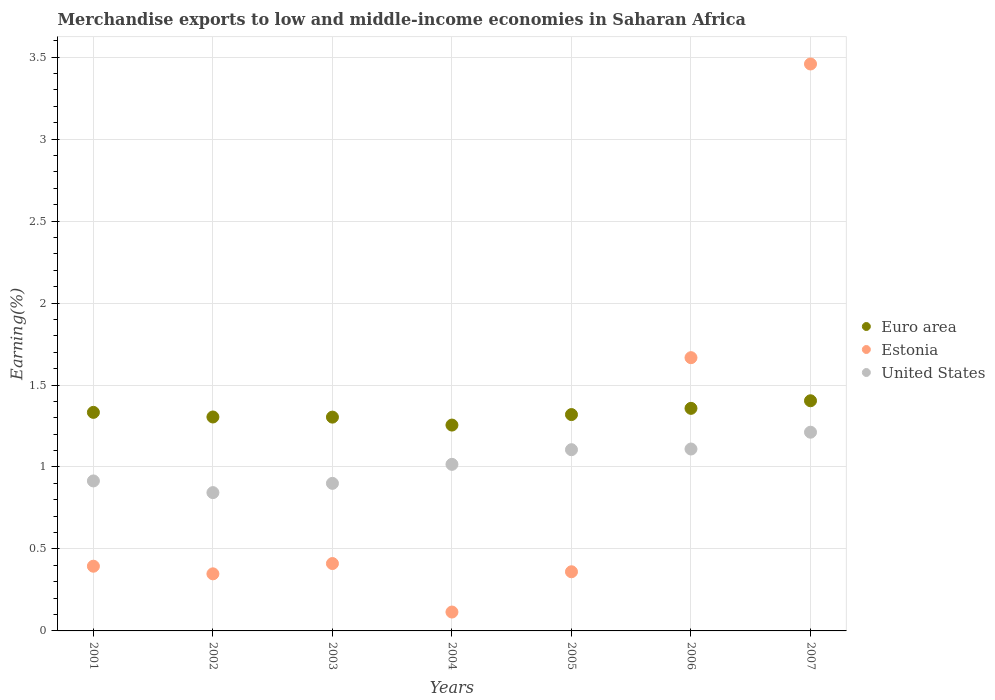How many different coloured dotlines are there?
Keep it short and to the point. 3. What is the percentage of amount earned from merchandise exports in United States in 2003?
Provide a succinct answer. 0.9. Across all years, what is the maximum percentage of amount earned from merchandise exports in Euro area?
Offer a very short reply. 1.4. Across all years, what is the minimum percentage of amount earned from merchandise exports in United States?
Provide a succinct answer. 0.84. In which year was the percentage of amount earned from merchandise exports in Estonia maximum?
Provide a short and direct response. 2007. In which year was the percentage of amount earned from merchandise exports in United States minimum?
Give a very brief answer. 2002. What is the total percentage of amount earned from merchandise exports in United States in the graph?
Provide a short and direct response. 7.1. What is the difference between the percentage of amount earned from merchandise exports in Estonia in 2002 and that in 2004?
Your answer should be compact. 0.23. What is the difference between the percentage of amount earned from merchandise exports in United States in 2006 and the percentage of amount earned from merchandise exports in Euro area in 2005?
Make the answer very short. -0.21. What is the average percentage of amount earned from merchandise exports in Estonia per year?
Make the answer very short. 0.97. In the year 2002, what is the difference between the percentage of amount earned from merchandise exports in Estonia and percentage of amount earned from merchandise exports in Euro area?
Provide a succinct answer. -0.96. What is the ratio of the percentage of amount earned from merchandise exports in United States in 2003 to that in 2006?
Offer a very short reply. 0.81. What is the difference between the highest and the second highest percentage of amount earned from merchandise exports in Euro area?
Your response must be concise. 0.05. What is the difference between the highest and the lowest percentage of amount earned from merchandise exports in Estonia?
Your answer should be very brief. 3.34. Is the sum of the percentage of amount earned from merchandise exports in Estonia in 2005 and 2006 greater than the maximum percentage of amount earned from merchandise exports in United States across all years?
Provide a succinct answer. Yes. Is it the case that in every year, the sum of the percentage of amount earned from merchandise exports in Euro area and percentage of amount earned from merchandise exports in United States  is greater than the percentage of amount earned from merchandise exports in Estonia?
Your response must be concise. No. Is the percentage of amount earned from merchandise exports in United States strictly greater than the percentage of amount earned from merchandise exports in Euro area over the years?
Offer a very short reply. No. Is the percentage of amount earned from merchandise exports in Euro area strictly less than the percentage of amount earned from merchandise exports in Estonia over the years?
Offer a terse response. No. How many dotlines are there?
Your answer should be compact. 3. Does the graph contain any zero values?
Give a very brief answer. No. How are the legend labels stacked?
Your response must be concise. Vertical. What is the title of the graph?
Keep it short and to the point. Merchandise exports to low and middle-income economies in Saharan Africa. Does "Dominica" appear as one of the legend labels in the graph?
Offer a terse response. No. What is the label or title of the X-axis?
Your response must be concise. Years. What is the label or title of the Y-axis?
Your answer should be compact. Earning(%). What is the Earning(%) in Euro area in 2001?
Provide a succinct answer. 1.33. What is the Earning(%) of Estonia in 2001?
Provide a succinct answer. 0.39. What is the Earning(%) in United States in 2001?
Provide a short and direct response. 0.91. What is the Earning(%) in Euro area in 2002?
Give a very brief answer. 1.31. What is the Earning(%) in Estonia in 2002?
Your response must be concise. 0.35. What is the Earning(%) in United States in 2002?
Ensure brevity in your answer.  0.84. What is the Earning(%) in Euro area in 2003?
Provide a succinct answer. 1.3. What is the Earning(%) of Estonia in 2003?
Make the answer very short. 0.41. What is the Earning(%) in United States in 2003?
Provide a succinct answer. 0.9. What is the Earning(%) of Euro area in 2004?
Provide a succinct answer. 1.26. What is the Earning(%) of Estonia in 2004?
Give a very brief answer. 0.12. What is the Earning(%) of United States in 2004?
Provide a short and direct response. 1.02. What is the Earning(%) in Euro area in 2005?
Keep it short and to the point. 1.32. What is the Earning(%) of Estonia in 2005?
Your answer should be very brief. 0.36. What is the Earning(%) in United States in 2005?
Offer a very short reply. 1.11. What is the Earning(%) of Euro area in 2006?
Offer a very short reply. 1.36. What is the Earning(%) of Estonia in 2006?
Give a very brief answer. 1.67. What is the Earning(%) in United States in 2006?
Offer a very short reply. 1.11. What is the Earning(%) of Euro area in 2007?
Your answer should be compact. 1.4. What is the Earning(%) in Estonia in 2007?
Ensure brevity in your answer.  3.46. What is the Earning(%) in United States in 2007?
Keep it short and to the point. 1.21. Across all years, what is the maximum Earning(%) of Euro area?
Provide a succinct answer. 1.4. Across all years, what is the maximum Earning(%) of Estonia?
Your answer should be very brief. 3.46. Across all years, what is the maximum Earning(%) in United States?
Offer a terse response. 1.21. Across all years, what is the minimum Earning(%) in Euro area?
Keep it short and to the point. 1.26. Across all years, what is the minimum Earning(%) in Estonia?
Offer a terse response. 0.12. Across all years, what is the minimum Earning(%) in United States?
Make the answer very short. 0.84. What is the total Earning(%) of Euro area in the graph?
Your answer should be very brief. 9.28. What is the total Earning(%) in Estonia in the graph?
Provide a short and direct response. 6.76. What is the total Earning(%) in United States in the graph?
Provide a short and direct response. 7.1. What is the difference between the Earning(%) of Euro area in 2001 and that in 2002?
Provide a succinct answer. 0.03. What is the difference between the Earning(%) in Estonia in 2001 and that in 2002?
Give a very brief answer. 0.05. What is the difference between the Earning(%) of United States in 2001 and that in 2002?
Your answer should be very brief. 0.07. What is the difference between the Earning(%) of Euro area in 2001 and that in 2003?
Keep it short and to the point. 0.03. What is the difference between the Earning(%) in Estonia in 2001 and that in 2003?
Make the answer very short. -0.02. What is the difference between the Earning(%) of United States in 2001 and that in 2003?
Give a very brief answer. 0.01. What is the difference between the Earning(%) in Euro area in 2001 and that in 2004?
Offer a very short reply. 0.08. What is the difference between the Earning(%) of Estonia in 2001 and that in 2004?
Your response must be concise. 0.28. What is the difference between the Earning(%) in United States in 2001 and that in 2004?
Offer a very short reply. -0.1. What is the difference between the Earning(%) of Euro area in 2001 and that in 2005?
Offer a terse response. 0.01. What is the difference between the Earning(%) in Estonia in 2001 and that in 2005?
Your answer should be compact. 0.03. What is the difference between the Earning(%) of United States in 2001 and that in 2005?
Give a very brief answer. -0.19. What is the difference between the Earning(%) in Euro area in 2001 and that in 2006?
Ensure brevity in your answer.  -0.02. What is the difference between the Earning(%) of Estonia in 2001 and that in 2006?
Provide a short and direct response. -1.27. What is the difference between the Earning(%) of United States in 2001 and that in 2006?
Provide a succinct answer. -0.19. What is the difference between the Earning(%) in Euro area in 2001 and that in 2007?
Your response must be concise. -0.07. What is the difference between the Earning(%) of Estonia in 2001 and that in 2007?
Make the answer very short. -3.06. What is the difference between the Earning(%) of United States in 2001 and that in 2007?
Your answer should be very brief. -0.3. What is the difference between the Earning(%) in Euro area in 2002 and that in 2003?
Ensure brevity in your answer.  0. What is the difference between the Earning(%) in Estonia in 2002 and that in 2003?
Ensure brevity in your answer.  -0.06. What is the difference between the Earning(%) of United States in 2002 and that in 2003?
Ensure brevity in your answer.  -0.06. What is the difference between the Earning(%) of Euro area in 2002 and that in 2004?
Give a very brief answer. 0.05. What is the difference between the Earning(%) of Estonia in 2002 and that in 2004?
Offer a terse response. 0.23. What is the difference between the Earning(%) of United States in 2002 and that in 2004?
Your answer should be very brief. -0.17. What is the difference between the Earning(%) in Euro area in 2002 and that in 2005?
Your answer should be very brief. -0.01. What is the difference between the Earning(%) of Estonia in 2002 and that in 2005?
Your response must be concise. -0.01. What is the difference between the Earning(%) of United States in 2002 and that in 2005?
Make the answer very short. -0.26. What is the difference between the Earning(%) in Euro area in 2002 and that in 2006?
Offer a very short reply. -0.05. What is the difference between the Earning(%) of Estonia in 2002 and that in 2006?
Give a very brief answer. -1.32. What is the difference between the Earning(%) in United States in 2002 and that in 2006?
Provide a short and direct response. -0.27. What is the difference between the Earning(%) in Euro area in 2002 and that in 2007?
Provide a short and direct response. -0.1. What is the difference between the Earning(%) of Estonia in 2002 and that in 2007?
Your response must be concise. -3.11. What is the difference between the Earning(%) of United States in 2002 and that in 2007?
Keep it short and to the point. -0.37. What is the difference between the Earning(%) of Euro area in 2003 and that in 2004?
Keep it short and to the point. 0.05. What is the difference between the Earning(%) of Estonia in 2003 and that in 2004?
Your response must be concise. 0.3. What is the difference between the Earning(%) of United States in 2003 and that in 2004?
Make the answer very short. -0.12. What is the difference between the Earning(%) of Euro area in 2003 and that in 2005?
Offer a very short reply. -0.02. What is the difference between the Earning(%) of Estonia in 2003 and that in 2005?
Provide a succinct answer. 0.05. What is the difference between the Earning(%) of United States in 2003 and that in 2005?
Offer a terse response. -0.21. What is the difference between the Earning(%) of Euro area in 2003 and that in 2006?
Your response must be concise. -0.05. What is the difference between the Earning(%) in Estonia in 2003 and that in 2006?
Offer a very short reply. -1.26. What is the difference between the Earning(%) in United States in 2003 and that in 2006?
Keep it short and to the point. -0.21. What is the difference between the Earning(%) in Euro area in 2003 and that in 2007?
Your answer should be very brief. -0.1. What is the difference between the Earning(%) of Estonia in 2003 and that in 2007?
Your response must be concise. -3.05. What is the difference between the Earning(%) in United States in 2003 and that in 2007?
Make the answer very short. -0.31. What is the difference between the Earning(%) in Euro area in 2004 and that in 2005?
Your response must be concise. -0.06. What is the difference between the Earning(%) of Estonia in 2004 and that in 2005?
Keep it short and to the point. -0.25. What is the difference between the Earning(%) of United States in 2004 and that in 2005?
Give a very brief answer. -0.09. What is the difference between the Earning(%) in Euro area in 2004 and that in 2006?
Your answer should be very brief. -0.1. What is the difference between the Earning(%) of Estonia in 2004 and that in 2006?
Keep it short and to the point. -1.55. What is the difference between the Earning(%) in United States in 2004 and that in 2006?
Your answer should be compact. -0.09. What is the difference between the Earning(%) in Euro area in 2004 and that in 2007?
Offer a terse response. -0.15. What is the difference between the Earning(%) of Estonia in 2004 and that in 2007?
Ensure brevity in your answer.  -3.34. What is the difference between the Earning(%) of United States in 2004 and that in 2007?
Make the answer very short. -0.2. What is the difference between the Earning(%) of Euro area in 2005 and that in 2006?
Your answer should be very brief. -0.04. What is the difference between the Earning(%) in Estonia in 2005 and that in 2006?
Provide a short and direct response. -1.31. What is the difference between the Earning(%) in United States in 2005 and that in 2006?
Provide a short and direct response. -0. What is the difference between the Earning(%) in Euro area in 2005 and that in 2007?
Your response must be concise. -0.08. What is the difference between the Earning(%) of Estonia in 2005 and that in 2007?
Give a very brief answer. -3.1. What is the difference between the Earning(%) in United States in 2005 and that in 2007?
Keep it short and to the point. -0.11. What is the difference between the Earning(%) of Euro area in 2006 and that in 2007?
Ensure brevity in your answer.  -0.05. What is the difference between the Earning(%) in Estonia in 2006 and that in 2007?
Make the answer very short. -1.79. What is the difference between the Earning(%) in United States in 2006 and that in 2007?
Give a very brief answer. -0.1. What is the difference between the Earning(%) in Euro area in 2001 and the Earning(%) in Estonia in 2002?
Provide a succinct answer. 0.98. What is the difference between the Earning(%) of Euro area in 2001 and the Earning(%) of United States in 2002?
Provide a short and direct response. 0.49. What is the difference between the Earning(%) in Estonia in 2001 and the Earning(%) in United States in 2002?
Keep it short and to the point. -0.45. What is the difference between the Earning(%) of Euro area in 2001 and the Earning(%) of Estonia in 2003?
Provide a succinct answer. 0.92. What is the difference between the Earning(%) of Euro area in 2001 and the Earning(%) of United States in 2003?
Your answer should be very brief. 0.43. What is the difference between the Earning(%) in Estonia in 2001 and the Earning(%) in United States in 2003?
Make the answer very short. -0.51. What is the difference between the Earning(%) in Euro area in 2001 and the Earning(%) in Estonia in 2004?
Make the answer very short. 1.22. What is the difference between the Earning(%) of Euro area in 2001 and the Earning(%) of United States in 2004?
Make the answer very short. 0.32. What is the difference between the Earning(%) in Estonia in 2001 and the Earning(%) in United States in 2004?
Your answer should be very brief. -0.62. What is the difference between the Earning(%) in Euro area in 2001 and the Earning(%) in Estonia in 2005?
Make the answer very short. 0.97. What is the difference between the Earning(%) in Euro area in 2001 and the Earning(%) in United States in 2005?
Provide a succinct answer. 0.23. What is the difference between the Earning(%) in Estonia in 2001 and the Earning(%) in United States in 2005?
Make the answer very short. -0.71. What is the difference between the Earning(%) in Euro area in 2001 and the Earning(%) in Estonia in 2006?
Give a very brief answer. -0.33. What is the difference between the Earning(%) of Euro area in 2001 and the Earning(%) of United States in 2006?
Keep it short and to the point. 0.22. What is the difference between the Earning(%) of Estonia in 2001 and the Earning(%) of United States in 2006?
Make the answer very short. -0.71. What is the difference between the Earning(%) in Euro area in 2001 and the Earning(%) in Estonia in 2007?
Your answer should be very brief. -2.13. What is the difference between the Earning(%) in Euro area in 2001 and the Earning(%) in United States in 2007?
Make the answer very short. 0.12. What is the difference between the Earning(%) in Estonia in 2001 and the Earning(%) in United States in 2007?
Your response must be concise. -0.82. What is the difference between the Earning(%) of Euro area in 2002 and the Earning(%) of Estonia in 2003?
Make the answer very short. 0.89. What is the difference between the Earning(%) of Euro area in 2002 and the Earning(%) of United States in 2003?
Keep it short and to the point. 0.4. What is the difference between the Earning(%) of Estonia in 2002 and the Earning(%) of United States in 2003?
Make the answer very short. -0.55. What is the difference between the Earning(%) of Euro area in 2002 and the Earning(%) of Estonia in 2004?
Offer a very short reply. 1.19. What is the difference between the Earning(%) of Euro area in 2002 and the Earning(%) of United States in 2004?
Keep it short and to the point. 0.29. What is the difference between the Earning(%) of Estonia in 2002 and the Earning(%) of United States in 2004?
Offer a very short reply. -0.67. What is the difference between the Earning(%) in Euro area in 2002 and the Earning(%) in Estonia in 2005?
Provide a short and direct response. 0.94. What is the difference between the Earning(%) in Euro area in 2002 and the Earning(%) in United States in 2005?
Offer a very short reply. 0.2. What is the difference between the Earning(%) in Estonia in 2002 and the Earning(%) in United States in 2005?
Give a very brief answer. -0.76. What is the difference between the Earning(%) of Euro area in 2002 and the Earning(%) of Estonia in 2006?
Provide a succinct answer. -0.36. What is the difference between the Earning(%) of Euro area in 2002 and the Earning(%) of United States in 2006?
Offer a very short reply. 0.2. What is the difference between the Earning(%) in Estonia in 2002 and the Earning(%) in United States in 2006?
Your answer should be very brief. -0.76. What is the difference between the Earning(%) in Euro area in 2002 and the Earning(%) in Estonia in 2007?
Your answer should be compact. -2.15. What is the difference between the Earning(%) of Euro area in 2002 and the Earning(%) of United States in 2007?
Your response must be concise. 0.09. What is the difference between the Earning(%) in Estonia in 2002 and the Earning(%) in United States in 2007?
Your response must be concise. -0.86. What is the difference between the Earning(%) in Euro area in 2003 and the Earning(%) in Estonia in 2004?
Make the answer very short. 1.19. What is the difference between the Earning(%) in Euro area in 2003 and the Earning(%) in United States in 2004?
Make the answer very short. 0.29. What is the difference between the Earning(%) in Estonia in 2003 and the Earning(%) in United States in 2004?
Your answer should be very brief. -0.61. What is the difference between the Earning(%) in Euro area in 2003 and the Earning(%) in Estonia in 2005?
Offer a terse response. 0.94. What is the difference between the Earning(%) in Euro area in 2003 and the Earning(%) in United States in 2005?
Ensure brevity in your answer.  0.2. What is the difference between the Earning(%) of Estonia in 2003 and the Earning(%) of United States in 2005?
Make the answer very short. -0.69. What is the difference between the Earning(%) in Euro area in 2003 and the Earning(%) in Estonia in 2006?
Ensure brevity in your answer.  -0.36. What is the difference between the Earning(%) of Euro area in 2003 and the Earning(%) of United States in 2006?
Offer a very short reply. 0.19. What is the difference between the Earning(%) of Estonia in 2003 and the Earning(%) of United States in 2006?
Offer a very short reply. -0.7. What is the difference between the Earning(%) in Euro area in 2003 and the Earning(%) in Estonia in 2007?
Keep it short and to the point. -2.15. What is the difference between the Earning(%) of Euro area in 2003 and the Earning(%) of United States in 2007?
Ensure brevity in your answer.  0.09. What is the difference between the Earning(%) of Estonia in 2003 and the Earning(%) of United States in 2007?
Keep it short and to the point. -0.8. What is the difference between the Earning(%) in Euro area in 2004 and the Earning(%) in Estonia in 2005?
Make the answer very short. 0.89. What is the difference between the Earning(%) in Euro area in 2004 and the Earning(%) in United States in 2005?
Give a very brief answer. 0.15. What is the difference between the Earning(%) of Estonia in 2004 and the Earning(%) of United States in 2005?
Provide a succinct answer. -0.99. What is the difference between the Earning(%) of Euro area in 2004 and the Earning(%) of Estonia in 2006?
Give a very brief answer. -0.41. What is the difference between the Earning(%) in Euro area in 2004 and the Earning(%) in United States in 2006?
Your answer should be very brief. 0.15. What is the difference between the Earning(%) in Estonia in 2004 and the Earning(%) in United States in 2006?
Your answer should be compact. -0.99. What is the difference between the Earning(%) of Euro area in 2004 and the Earning(%) of Estonia in 2007?
Offer a very short reply. -2.2. What is the difference between the Earning(%) of Euro area in 2004 and the Earning(%) of United States in 2007?
Offer a terse response. 0.04. What is the difference between the Earning(%) of Estonia in 2004 and the Earning(%) of United States in 2007?
Your answer should be compact. -1.1. What is the difference between the Earning(%) in Euro area in 2005 and the Earning(%) in Estonia in 2006?
Give a very brief answer. -0.35. What is the difference between the Earning(%) of Euro area in 2005 and the Earning(%) of United States in 2006?
Ensure brevity in your answer.  0.21. What is the difference between the Earning(%) of Estonia in 2005 and the Earning(%) of United States in 2006?
Your answer should be compact. -0.75. What is the difference between the Earning(%) in Euro area in 2005 and the Earning(%) in Estonia in 2007?
Your response must be concise. -2.14. What is the difference between the Earning(%) in Euro area in 2005 and the Earning(%) in United States in 2007?
Offer a terse response. 0.11. What is the difference between the Earning(%) in Estonia in 2005 and the Earning(%) in United States in 2007?
Your answer should be compact. -0.85. What is the difference between the Earning(%) of Euro area in 2006 and the Earning(%) of Estonia in 2007?
Offer a very short reply. -2.1. What is the difference between the Earning(%) of Euro area in 2006 and the Earning(%) of United States in 2007?
Offer a terse response. 0.15. What is the difference between the Earning(%) of Estonia in 2006 and the Earning(%) of United States in 2007?
Your answer should be very brief. 0.45. What is the average Earning(%) of Euro area per year?
Offer a very short reply. 1.33. What is the average Earning(%) of Estonia per year?
Offer a terse response. 0.97. What is the average Earning(%) of United States per year?
Keep it short and to the point. 1.01. In the year 2001, what is the difference between the Earning(%) in Euro area and Earning(%) in Estonia?
Your answer should be very brief. 0.94. In the year 2001, what is the difference between the Earning(%) in Euro area and Earning(%) in United States?
Your response must be concise. 0.42. In the year 2001, what is the difference between the Earning(%) of Estonia and Earning(%) of United States?
Your response must be concise. -0.52. In the year 2002, what is the difference between the Earning(%) of Euro area and Earning(%) of Estonia?
Make the answer very short. 0.96. In the year 2002, what is the difference between the Earning(%) in Euro area and Earning(%) in United States?
Offer a terse response. 0.46. In the year 2002, what is the difference between the Earning(%) in Estonia and Earning(%) in United States?
Keep it short and to the point. -0.5. In the year 2003, what is the difference between the Earning(%) of Euro area and Earning(%) of Estonia?
Ensure brevity in your answer.  0.89. In the year 2003, what is the difference between the Earning(%) in Euro area and Earning(%) in United States?
Make the answer very short. 0.4. In the year 2003, what is the difference between the Earning(%) of Estonia and Earning(%) of United States?
Make the answer very short. -0.49. In the year 2004, what is the difference between the Earning(%) in Euro area and Earning(%) in Estonia?
Provide a short and direct response. 1.14. In the year 2004, what is the difference between the Earning(%) in Euro area and Earning(%) in United States?
Your response must be concise. 0.24. In the year 2004, what is the difference between the Earning(%) of Estonia and Earning(%) of United States?
Keep it short and to the point. -0.9. In the year 2005, what is the difference between the Earning(%) in Euro area and Earning(%) in Estonia?
Keep it short and to the point. 0.96. In the year 2005, what is the difference between the Earning(%) in Euro area and Earning(%) in United States?
Your answer should be very brief. 0.21. In the year 2005, what is the difference between the Earning(%) of Estonia and Earning(%) of United States?
Provide a short and direct response. -0.74. In the year 2006, what is the difference between the Earning(%) in Euro area and Earning(%) in Estonia?
Offer a very short reply. -0.31. In the year 2006, what is the difference between the Earning(%) of Euro area and Earning(%) of United States?
Keep it short and to the point. 0.25. In the year 2006, what is the difference between the Earning(%) in Estonia and Earning(%) in United States?
Your answer should be compact. 0.56. In the year 2007, what is the difference between the Earning(%) of Euro area and Earning(%) of Estonia?
Your response must be concise. -2.05. In the year 2007, what is the difference between the Earning(%) in Euro area and Earning(%) in United States?
Your answer should be very brief. 0.19. In the year 2007, what is the difference between the Earning(%) in Estonia and Earning(%) in United States?
Your answer should be compact. 2.25. What is the ratio of the Earning(%) of Euro area in 2001 to that in 2002?
Keep it short and to the point. 1.02. What is the ratio of the Earning(%) in Estonia in 2001 to that in 2002?
Your answer should be compact. 1.13. What is the ratio of the Earning(%) of United States in 2001 to that in 2002?
Provide a short and direct response. 1.08. What is the ratio of the Earning(%) of Euro area in 2001 to that in 2003?
Provide a succinct answer. 1.02. What is the ratio of the Earning(%) of Estonia in 2001 to that in 2003?
Ensure brevity in your answer.  0.96. What is the ratio of the Earning(%) of United States in 2001 to that in 2003?
Make the answer very short. 1.02. What is the ratio of the Earning(%) of Euro area in 2001 to that in 2004?
Keep it short and to the point. 1.06. What is the ratio of the Earning(%) in Estonia in 2001 to that in 2004?
Your answer should be very brief. 3.43. What is the ratio of the Earning(%) of United States in 2001 to that in 2004?
Keep it short and to the point. 0.9. What is the ratio of the Earning(%) of Euro area in 2001 to that in 2005?
Keep it short and to the point. 1.01. What is the ratio of the Earning(%) in Estonia in 2001 to that in 2005?
Ensure brevity in your answer.  1.09. What is the ratio of the Earning(%) of United States in 2001 to that in 2005?
Your answer should be very brief. 0.83. What is the ratio of the Earning(%) of Euro area in 2001 to that in 2006?
Offer a terse response. 0.98. What is the ratio of the Earning(%) of Estonia in 2001 to that in 2006?
Keep it short and to the point. 0.24. What is the ratio of the Earning(%) in United States in 2001 to that in 2006?
Keep it short and to the point. 0.82. What is the ratio of the Earning(%) in Euro area in 2001 to that in 2007?
Keep it short and to the point. 0.95. What is the ratio of the Earning(%) of Estonia in 2001 to that in 2007?
Offer a terse response. 0.11. What is the ratio of the Earning(%) of United States in 2001 to that in 2007?
Make the answer very short. 0.75. What is the ratio of the Earning(%) in Estonia in 2002 to that in 2003?
Make the answer very short. 0.85. What is the ratio of the Earning(%) in United States in 2002 to that in 2003?
Ensure brevity in your answer.  0.94. What is the ratio of the Earning(%) in Euro area in 2002 to that in 2004?
Your answer should be very brief. 1.04. What is the ratio of the Earning(%) of Estonia in 2002 to that in 2004?
Your response must be concise. 3.02. What is the ratio of the Earning(%) of United States in 2002 to that in 2004?
Provide a short and direct response. 0.83. What is the ratio of the Earning(%) in Euro area in 2002 to that in 2005?
Give a very brief answer. 0.99. What is the ratio of the Earning(%) of United States in 2002 to that in 2005?
Ensure brevity in your answer.  0.76. What is the ratio of the Earning(%) of Euro area in 2002 to that in 2006?
Your response must be concise. 0.96. What is the ratio of the Earning(%) of Estonia in 2002 to that in 2006?
Give a very brief answer. 0.21. What is the ratio of the Earning(%) in United States in 2002 to that in 2006?
Your answer should be very brief. 0.76. What is the ratio of the Earning(%) of Euro area in 2002 to that in 2007?
Offer a very short reply. 0.93. What is the ratio of the Earning(%) in Estonia in 2002 to that in 2007?
Provide a short and direct response. 0.1. What is the ratio of the Earning(%) in United States in 2002 to that in 2007?
Your response must be concise. 0.7. What is the ratio of the Earning(%) of Euro area in 2003 to that in 2004?
Offer a terse response. 1.04. What is the ratio of the Earning(%) of Estonia in 2003 to that in 2004?
Offer a very short reply. 3.57. What is the ratio of the Earning(%) of United States in 2003 to that in 2004?
Provide a short and direct response. 0.89. What is the ratio of the Earning(%) of Euro area in 2003 to that in 2005?
Provide a short and direct response. 0.99. What is the ratio of the Earning(%) in Estonia in 2003 to that in 2005?
Give a very brief answer. 1.14. What is the ratio of the Earning(%) in United States in 2003 to that in 2005?
Ensure brevity in your answer.  0.81. What is the ratio of the Earning(%) of Euro area in 2003 to that in 2006?
Provide a short and direct response. 0.96. What is the ratio of the Earning(%) of Estonia in 2003 to that in 2006?
Your answer should be compact. 0.25. What is the ratio of the Earning(%) of United States in 2003 to that in 2006?
Provide a succinct answer. 0.81. What is the ratio of the Earning(%) of Euro area in 2003 to that in 2007?
Keep it short and to the point. 0.93. What is the ratio of the Earning(%) of Estonia in 2003 to that in 2007?
Your answer should be compact. 0.12. What is the ratio of the Earning(%) in United States in 2003 to that in 2007?
Offer a very short reply. 0.74. What is the ratio of the Earning(%) in Euro area in 2004 to that in 2005?
Provide a short and direct response. 0.95. What is the ratio of the Earning(%) in Estonia in 2004 to that in 2005?
Offer a terse response. 0.32. What is the ratio of the Earning(%) in United States in 2004 to that in 2005?
Your answer should be very brief. 0.92. What is the ratio of the Earning(%) in Euro area in 2004 to that in 2006?
Your response must be concise. 0.92. What is the ratio of the Earning(%) in Estonia in 2004 to that in 2006?
Offer a terse response. 0.07. What is the ratio of the Earning(%) of United States in 2004 to that in 2006?
Your answer should be very brief. 0.92. What is the ratio of the Earning(%) in Euro area in 2004 to that in 2007?
Your response must be concise. 0.89. What is the ratio of the Earning(%) in Estonia in 2004 to that in 2007?
Your answer should be very brief. 0.03. What is the ratio of the Earning(%) in United States in 2004 to that in 2007?
Your response must be concise. 0.84. What is the ratio of the Earning(%) in Estonia in 2005 to that in 2006?
Your answer should be compact. 0.22. What is the ratio of the Earning(%) of Estonia in 2005 to that in 2007?
Offer a very short reply. 0.1. What is the ratio of the Earning(%) in United States in 2005 to that in 2007?
Give a very brief answer. 0.91. What is the ratio of the Earning(%) in Euro area in 2006 to that in 2007?
Your response must be concise. 0.97. What is the ratio of the Earning(%) in Estonia in 2006 to that in 2007?
Your response must be concise. 0.48. What is the ratio of the Earning(%) in United States in 2006 to that in 2007?
Your response must be concise. 0.92. What is the difference between the highest and the second highest Earning(%) in Euro area?
Offer a very short reply. 0.05. What is the difference between the highest and the second highest Earning(%) in Estonia?
Your response must be concise. 1.79. What is the difference between the highest and the second highest Earning(%) in United States?
Give a very brief answer. 0.1. What is the difference between the highest and the lowest Earning(%) of Euro area?
Make the answer very short. 0.15. What is the difference between the highest and the lowest Earning(%) of Estonia?
Give a very brief answer. 3.34. What is the difference between the highest and the lowest Earning(%) of United States?
Provide a short and direct response. 0.37. 